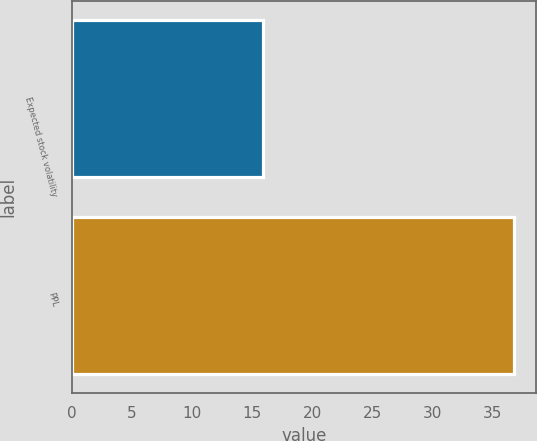Convert chart to OTSL. <chart><loc_0><loc_0><loc_500><loc_500><bar_chart><fcel>Expected stock volatility<fcel>PPL<nl><fcel>15.9<fcel>36.76<nl></chart> 